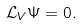<formula> <loc_0><loc_0><loc_500><loc_500>\mathcal { L } _ { V } \Psi = 0 .</formula> 